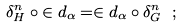Convert formula to latex. <formula><loc_0><loc_0><loc_500><loc_500>\delta ^ { n } _ { H } \circ { \in d _ { \alpha } } = \in d _ { \alpha } \circ { \delta ^ { n } _ { G } } \ ;</formula> 